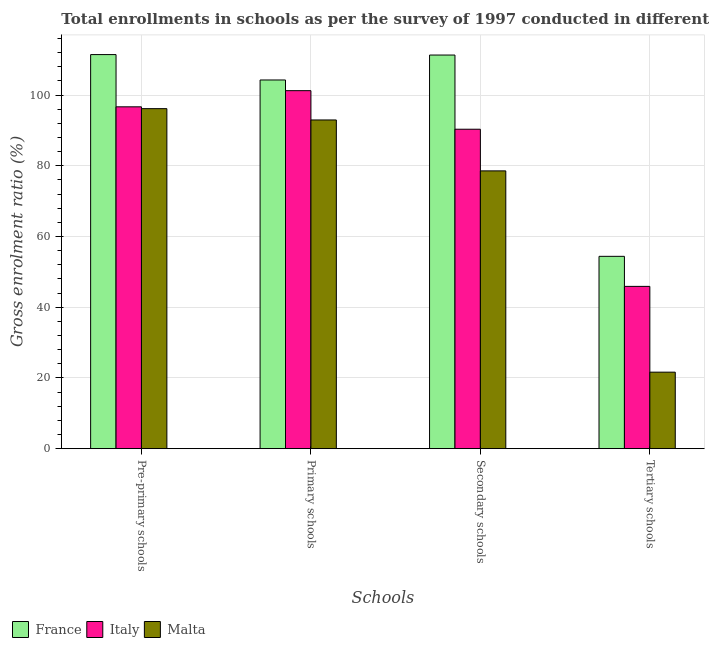How many different coloured bars are there?
Ensure brevity in your answer.  3. How many bars are there on the 2nd tick from the left?
Provide a short and direct response. 3. How many bars are there on the 4th tick from the right?
Your answer should be compact. 3. What is the label of the 3rd group of bars from the left?
Ensure brevity in your answer.  Secondary schools. What is the gross enrolment ratio in tertiary schools in Malta?
Make the answer very short. 21.64. Across all countries, what is the maximum gross enrolment ratio in primary schools?
Offer a terse response. 104.27. Across all countries, what is the minimum gross enrolment ratio in tertiary schools?
Keep it short and to the point. 21.64. In which country was the gross enrolment ratio in pre-primary schools maximum?
Offer a terse response. France. In which country was the gross enrolment ratio in secondary schools minimum?
Your answer should be very brief. Malta. What is the total gross enrolment ratio in pre-primary schools in the graph?
Make the answer very short. 304.29. What is the difference between the gross enrolment ratio in primary schools in Italy and that in Malta?
Provide a succinct answer. 8.29. What is the difference between the gross enrolment ratio in primary schools in Italy and the gross enrolment ratio in tertiary schools in France?
Your response must be concise. 46.86. What is the average gross enrolment ratio in secondary schools per country?
Give a very brief answer. 93.41. What is the difference between the gross enrolment ratio in pre-primary schools and gross enrolment ratio in tertiary schools in Italy?
Provide a short and direct response. 50.78. In how many countries, is the gross enrolment ratio in tertiary schools greater than 20 %?
Your response must be concise. 3. What is the ratio of the gross enrolment ratio in secondary schools in Italy to that in France?
Your answer should be very brief. 0.81. Is the gross enrolment ratio in tertiary schools in Italy less than that in Malta?
Ensure brevity in your answer.  No. Is the difference between the gross enrolment ratio in pre-primary schools in Italy and Malta greater than the difference between the gross enrolment ratio in primary schools in Italy and Malta?
Keep it short and to the point. No. What is the difference between the highest and the second highest gross enrolment ratio in tertiary schools?
Your response must be concise. 8.5. What is the difference between the highest and the lowest gross enrolment ratio in secondary schools?
Your answer should be very brief. 32.76. In how many countries, is the gross enrolment ratio in secondary schools greater than the average gross enrolment ratio in secondary schools taken over all countries?
Your response must be concise. 1. Is the sum of the gross enrolment ratio in secondary schools in Malta and France greater than the maximum gross enrolment ratio in primary schools across all countries?
Your response must be concise. Yes. Is it the case that in every country, the sum of the gross enrolment ratio in primary schools and gross enrolment ratio in secondary schools is greater than the sum of gross enrolment ratio in pre-primary schools and gross enrolment ratio in tertiary schools?
Ensure brevity in your answer.  No. What does the 1st bar from the right in Pre-primary schools represents?
Offer a terse response. Malta. How many countries are there in the graph?
Provide a short and direct response. 3. What is the difference between two consecutive major ticks on the Y-axis?
Make the answer very short. 20. Does the graph contain any zero values?
Offer a very short reply. No. Where does the legend appear in the graph?
Your answer should be very brief. Bottom left. How many legend labels are there?
Your answer should be compact. 3. How are the legend labels stacked?
Keep it short and to the point. Horizontal. What is the title of the graph?
Provide a succinct answer. Total enrollments in schools as per the survey of 1997 conducted in different countries. What is the label or title of the X-axis?
Make the answer very short. Schools. What is the label or title of the Y-axis?
Make the answer very short. Gross enrolment ratio (%). What is the Gross enrolment ratio (%) in France in Pre-primary schools?
Provide a short and direct response. 111.45. What is the Gross enrolment ratio (%) of Italy in Pre-primary schools?
Keep it short and to the point. 96.68. What is the Gross enrolment ratio (%) of Malta in Pre-primary schools?
Keep it short and to the point. 96.16. What is the Gross enrolment ratio (%) of France in Primary schools?
Your answer should be compact. 104.27. What is the Gross enrolment ratio (%) in Italy in Primary schools?
Give a very brief answer. 101.25. What is the Gross enrolment ratio (%) in Malta in Primary schools?
Offer a very short reply. 92.96. What is the Gross enrolment ratio (%) of France in Secondary schools?
Offer a very short reply. 111.32. What is the Gross enrolment ratio (%) in Italy in Secondary schools?
Ensure brevity in your answer.  90.34. What is the Gross enrolment ratio (%) in Malta in Secondary schools?
Give a very brief answer. 78.56. What is the Gross enrolment ratio (%) in France in Tertiary schools?
Your answer should be compact. 54.39. What is the Gross enrolment ratio (%) in Italy in Tertiary schools?
Keep it short and to the point. 45.9. What is the Gross enrolment ratio (%) of Malta in Tertiary schools?
Provide a succinct answer. 21.64. Across all Schools, what is the maximum Gross enrolment ratio (%) of France?
Keep it short and to the point. 111.45. Across all Schools, what is the maximum Gross enrolment ratio (%) of Italy?
Keep it short and to the point. 101.25. Across all Schools, what is the maximum Gross enrolment ratio (%) in Malta?
Your answer should be compact. 96.16. Across all Schools, what is the minimum Gross enrolment ratio (%) of France?
Offer a very short reply. 54.39. Across all Schools, what is the minimum Gross enrolment ratio (%) in Italy?
Offer a terse response. 45.9. Across all Schools, what is the minimum Gross enrolment ratio (%) of Malta?
Offer a very short reply. 21.64. What is the total Gross enrolment ratio (%) of France in the graph?
Offer a terse response. 381.43. What is the total Gross enrolment ratio (%) in Italy in the graph?
Provide a succinct answer. 334.16. What is the total Gross enrolment ratio (%) in Malta in the graph?
Give a very brief answer. 289.32. What is the difference between the Gross enrolment ratio (%) in France in Pre-primary schools and that in Primary schools?
Ensure brevity in your answer.  7.18. What is the difference between the Gross enrolment ratio (%) of Italy in Pre-primary schools and that in Primary schools?
Offer a terse response. -4.57. What is the difference between the Gross enrolment ratio (%) in Malta in Pre-primary schools and that in Primary schools?
Provide a short and direct response. 3.2. What is the difference between the Gross enrolment ratio (%) of France in Pre-primary schools and that in Secondary schools?
Your answer should be compact. 0.13. What is the difference between the Gross enrolment ratio (%) of Italy in Pre-primary schools and that in Secondary schools?
Ensure brevity in your answer.  6.34. What is the difference between the Gross enrolment ratio (%) in Malta in Pre-primary schools and that in Secondary schools?
Your response must be concise. 17.6. What is the difference between the Gross enrolment ratio (%) of France in Pre-primary schools and that in Tertiary schools?
Keep it short and to the point. 57.06. What is the difference between the Gross enrolment ratio (%) in Italy in Pre-primary schools and that in Tertiary schools?
Provide a succinct answer. 50.78. What is the difference between the Gross enrolment ratio (%) in Malta in Pre-primary schools and that in Tertiary schools?
Your response must be concise. 74.52. What is the difference between the Gross enrolment ratio (%) in France in Primary schools and that in Secondary schools?
Your response must be concise. -7.05. What is the difference between the Gross enrolment ratio (%) in Italy in Primary schools and that in Secondary schools?
Offer a terse response. 10.91. What is the difference between the Gross enrolment ratio (%) in Malta in Primary schools and that in Secondary schools?
Provide a succinct answer. 14.4. What is the difference between the Gross enrolment ratio (%) of France in Primary schools and that in Tertiary schools?
Offer a terse response. 49.88. What is the difference between the Gross enrolment ratio (%) in Italy in Primary schools and that in Tertiary schools?
Offer a very short reply. 55.35. What is the difference between the Gross enrolment ratio (%) of Malta in Primary schools and that in Tertiary schools?
Keep it short and to the point. 71.33. What is the difference between the Gross enrolment ratio (%) in France in Secondary schools and that in Tertiary schools?
Your response must be concise. 56.93. What is the difference between the Gross enrolment ratio (%) in Italy in Secondary schools and that in Tertiary schools?
Your answer should be compact. 44.44. What is the difference between the Gross enrolment ratio (%) of Malta in Secondary schools and that in Tertiary schools?
Ensure brevity in your answer.  56.93. What is the difference between the Gross enrolment ratio (%) of France in Pre-primary schools and the Gross enrolment ratio (%) of Italy in Primary schools?
Your response must be concise. 10.2. What is the difference between the Gross enrolment ratio (%) of France in Pre-primary schools and the Gross enrolment ratio (%) of Malta in Primary schools?
Your response must be concise. 18.49. What is the difference between the Gross enrolment ratio (%) in Italy in Pre-primary schools and the Gross enrolment ratio (%) in Malta in Primary schools?
Offer a terse response. 3.72. What is the difference between the Gross enrolment ratio (%) in France in Pre-primary schools and the Gross enrolment ratio (%) in Italy in Secondary schools?
Ensure brevity in your answer.  21.11. What is the difference between the Gross enrolment ratio (%) in France in Pre-primary schools and the Gross enrolment ratio (%) in Malta in Secondary schools?
Offer a terse response. 32.89. What is the difference between the Gross enrolment ratio (%) in Italy in Pre-primary schools and the Gross enrolment ratio (%) in Malta in Secondary schools?
Keep it short and to the point. 18.12. What is the difference between the Gross enrolment ratio (%) in France in Pre-primary schools and the Gross enrolment ratio (%) in Italy in Tertiary schools?
Your response must be concise. 65.55. What is the difference between the Gross enrolment ratio (%) of France in Pre-primary schools and the Gross enrolment ratio (%) of Malta in Tertiary schools?
Give a very brief answer. 89.81. What is the difference between the Gross enrolment ratio (%) of Italy in Pre-primary schools and the Gross enrolment ratio (%) of Malta in Tertiary schools?
Ensure brevity in your answer.  75.04. What is the difference between the Gross enrolment ratio (%) of France in Primary schools and the Gross enrolment ratio (%) of Italy in Secondary schools?
Provide a short and direct response. 13.93. What is the difference between the Gross enrolment ratio (%) of France in Primary schools and the Gross enrolment ratio (%) of Malta in Secondary schools?
Provide a succinct answer. 25.71. What is the difference between the Gross enrolment ratio (%) in Italy in Primary schools and the Gross enrolment ratio (%) in Malta in Secondary schools?
Provide a short and direct response. 22.69. What is the difference between the Gross enrolment ratio (%) in France in Primary schools and the Gross enrolment ratio (%) in Italy in Tertiary schools?
Offer a terse response. 58.37. What is the difference between the Gross enrolment ratio (%) of France in Primary schools and the Gross enrolment ratio (%) of Malta in Tertiary schools?
Your answer should be very brief. 82.63. What is the difference between the Gross enrolment ratio (%) in Italy in Primary schools and the Gross enrolment ratio (%) in Malta in Tertiary schools?
Your response must be concise. 79.61. What is the difference between the Gross enrolment ratio (%) of France in Secondary schools and the Gross enrolment ratio (%) of Italy in Tertiary schools?
Provide a succinct answer. 65.43. What is the difference between the Gross enrolment ratio (%) in France in Secondary schools and the Gross enrolment ratio (%) in Malta in Tertiary schools?
Your answer should be very brief. 89.69. What is the difference between the Gross enrolment ratio (%) in Italy in Secondary schools and the Gross enrolment ratio (%) in Malta in Tertiary schools?
Offer a very short reply. 68.7. What is the average Gross enrolment ratio (%) in France per Schools?
Offer a very short reply. 95.36. What is the average Gross enrolment ratio (%) in Italy per Schools?
Your answer should be compact. 83.54. What is the average Gross enrolment ratio (%) of Malta per Schools?
Offer a very short reply. 72.33. What is the difference between the Gross enrolment ratio (%) in France and Gross enrolment ratio (%) in Italy in Pre-primary schools?
Ensure brevity in your answer.  14.77. What is the difference between the Gross enrolment ratio (%) in France and Gross enrolment ratio (%) in Malta in Pre-primary schools?
Make the answer very short. 15.29. What is the difference between the Gross enrolment ratio (%) of Italy and Gross enrolment ratio (%) of Malta in Pre-primary schools?
Offer a terse response. 0.52. What is the difference between the Gross enrolment ratio (%) in France and Gross enrolment ratio (%) in Italy in Primary schools?
Make the answer very short. 3.02. What is the difference between the Gross enrolment ratio (%) in France and Gross enrolment ratio (%) in Malta in Primary schools?
Keep it short and to the point. 11.31. What is the difference between the Gross enrolment ratio (%) of Italy and Gross enrolment ratio (%) of Malta in Primary schools?
Give a very brief answer. 8.29. What is the difference between the Gross enrolment ratio (%) of France and Gross enrolment ratio (%) of Italy in Secondary schools?
Make the answer very short. 20.98. What is the difference between the Gross enrolment ratio (%) of France and Gross enrolment ratio (%) of Malta in Secondary schools?
Provide a succinct answer. 32.76. What is the difference between the Gross enrolment ratio (%) in Italy and Gross enrolment ratio (%) in Malta in Secondary schools?
Provide a short and direct response. 11.78. What is the difference between the Gross enrolment ratio (%) of France and Gross enrolment ratio (%) of Italy in Tertiary schools?
Ensure brevity in your answer.  8.5. What is the difference between the Gross enrolment ratio (%) in France and Gross enrolment ratio (%) in Malta in Tertiary schools?
Provide a short and direct response. 32.76. What is the difference between the Gross enrolment ratio (%) of Italy and Gross enrolment ratio (%) of Malta in Tertiary schools?
Offer a terse response. 24.26. What is the ratio of the Gross enrolment ratio (%) in France in Pre-primary schools to that in Primary schools?
Offer a very short reply. 1.07. What is the ratio of the Gross enrolment ratio (%) in Italy in Pre-primary schools to that in Primary schools?
Ensure brevity in your answer.  0.95. What is the ratio of the Gross enrolment ratio (%) of Malta in Pre-primary schools to that in Primary schools?
Your response must be concise. 1.03. What is the ratio of the Gross enrolment ratio (%) in France in Pre-primary schools to that in Secondary schools?
Give a very brief answer. 1. What is the ratio of the Gross enrolment ratio (%) in Italy in Pre-primary schools to that in Secondary schools?
Your answer should be compact. 1.07. What is the ratio of the Gross enrolment ratio (%) of Malta in Pre-primary schools to that in Secondary schools?
Offer a terse response. 1.22. What is the ratio of the Gross enrolment ratio (%) in France in Pre-primary schools to that in Tertiary schools?
Keep it short and to the point. 2.05. What is the ratio of the Gross enrolment ratio (%) in Italy in Pre-primary schools to that in Tertiary schools?
Offer a terse response. 2.11. What is the ratio of the Gross enrolment ratio (%) of Malta in Pre-primary schools to that in Tertiary schools?
Your answer should be compact. 4.44. What is the ratio of the Gross enrolment ratio (%) of France in Primary schools to that in Secondary schools?
Your answer should be very brief. 0.94. What is the ratio of the Gross enrolment ratio (%) of Italy in Primary schools to that in Secondary schools?
Your response must be concise. 1.12. What is the ratio of the Gross enrolment ratio (%) of Malta in Primary schools to that in Secondary schools?
Provide a short and direct response. 1.18. What is the ratio of the Gross enrolment ratio (%) in France in Primary schools to that in Tertiary schools?
Your answer should be very brief. 1.92. What is the ratio of the Gross enrolment ratio (%) in Italy in Primary schools to that in Tertiary schools?
Your response must be concise. 2.21. What is the ratio of the Gross enrolment ratio (%) of Malta in Primary schools to that in Tertiary schools?
Offer a terse response. 4.3. What is the ratio of the Gross enrolment ratio (%) of France in Secondary schools to that in Tertiary schools?
Ensure brevity in your answer.  2.05. What is the ratio of the Gross enrolment ratio (%) of Italy in Secondary schools to that in Tertiary schools?
Give a very brief answer. 1.97. What is the ratio of the Gross enrolment ratio (%) in Malta in Secondary schools to that in Tertiary schools?
Your answer should be compact. 3.63. What is the difference between the highest and the second highest Gross enrolment ratio (%) of France?
Ensure brevity in your answer.  0.13. What is the difference between the highest and the second highest Gross enrolment ratio (%) of Italy?
Provide a short and direct response. 4.57. What is the difference between the highest and the second highest Gross enrolment ratio (%) in Malta?
Your response must be concise. 3.2. What is the difference between the highest and the lowest Gross enrolment ratio (%) in France?
Offer a terse response. 57.06. What is the difference between the highest and the lowest Gross enrolment ratio (%) in Italy?
Provide a short and direct response. 55.35. What is the difference between the highest and the lowest Gross enrolment ratio (%) of Malta?
Provide a succinct answer. 74.52. 